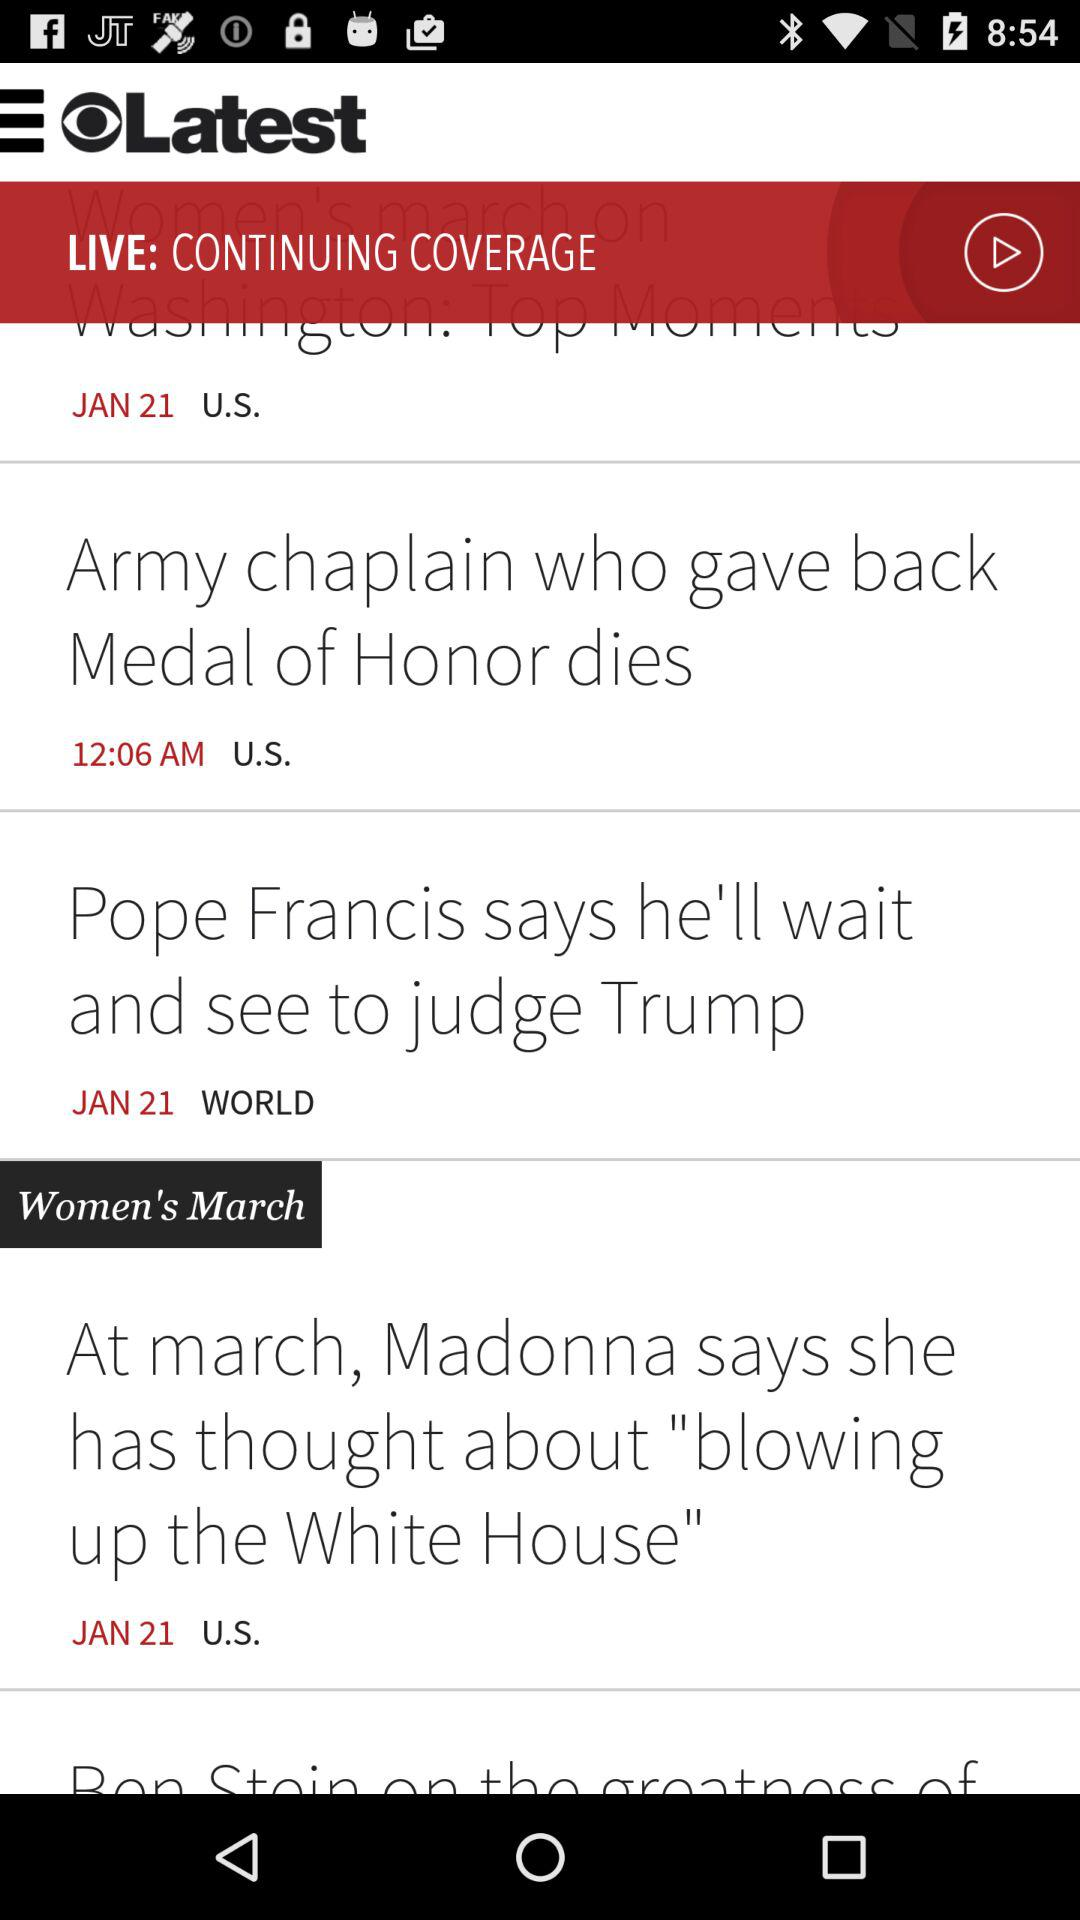What is the women's march news? The women's march news is At march, Madonna says she has thought about "blowing up the White House". 